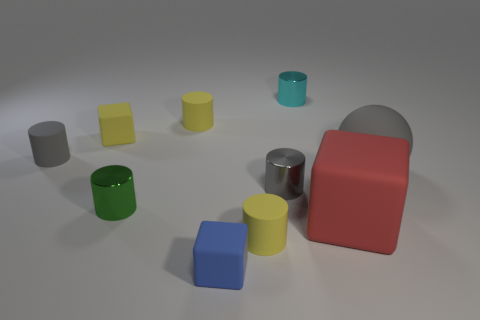Is there any indication of lighting or texture that is noteworthy? The objects have a matte surface and subtle shadows, suggesting a soft, diffused lighting environment. The smooth textures and soft lighting give the scene a calm and clean aesthetic, which might imply a controlled setting, like a studio for product photography. 